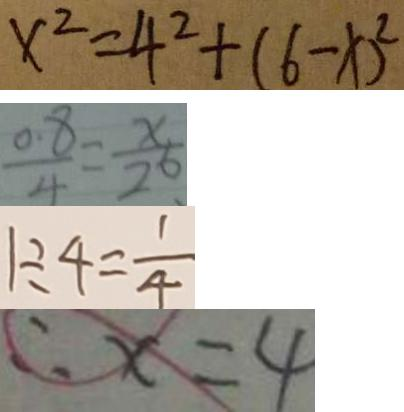<formula> <loc_0><loc_0><loc_500><loc_500>x ^ { 2 } = 4 ^ { 2 } + ( 6 - x ) ^ { 2 } 
 \frac { 0 . 8 } { 4 } = \frac { x } { 2 0 } 
 1 \div 4 = \frac { 1 } { 4 } 
 \therefore x = 4</formula> 